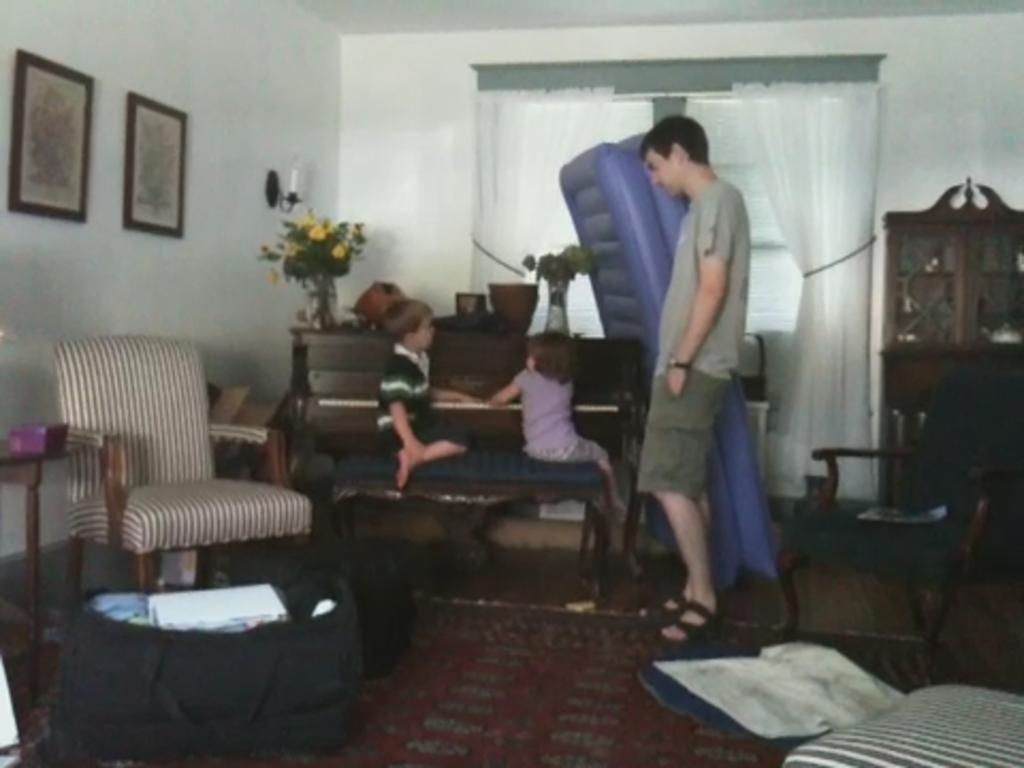Who are the people in the image? There is a boy, a girl, and a man in the image. What are the boy and girl doing in the image? The boy and girl are playing with a piano. What is the man doing in the image? The man is standing beside the boy and girl. What flavor of apples can be seen in the image? There are no apples present in the image. Can you describe the deer in the image? There are no deer present in the image. 